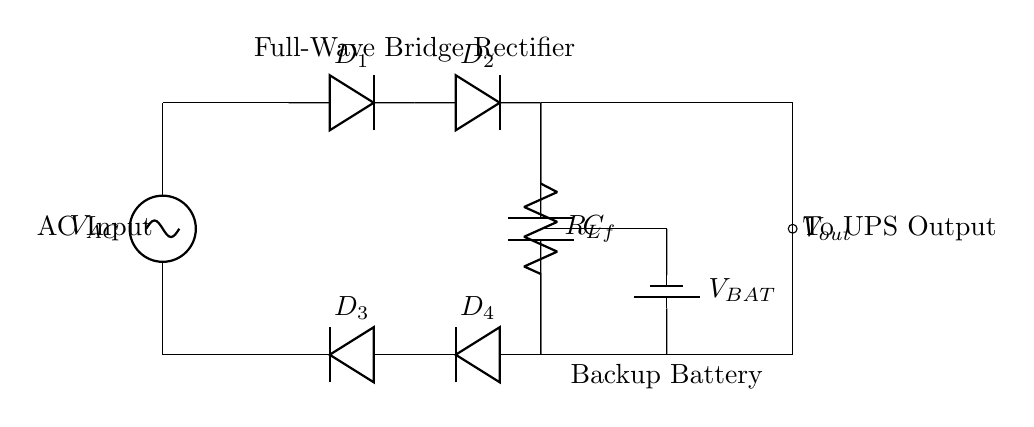What is the type of rectifier used in this circuit? The circuit diagram shows a full-wave bridge rectifier, which is designed to convert alternating current to direct current using four diodes arranged in a bridge configuration.
Answer: full-wave bridge rectifier How many diodes are in the circuit? The circuit contains four diodes, labeled D1, D2, D3, and D4, which are configured to create the bridge rectifier functionality.
Answer: four What does the capacitor C_f do in the circuit? Capacitor C_f serves to smooth the output voltage from the rectifier by filtering out fluctuations and providing a more stable direct current output, which is important for the load and battery charging.
Answer: smooth output voltage What is the purpose of the battery in this UPS system? The battery provides backup power to the load during power outages or disruptions in the AC input, ensuring that critical systems in the server room continue to operate without interruption.
Answer: backup power What is the role of the load resistor R_L? The load resistor R_L represents the connected device or system that consumes the output power from the rectifier, simulating the real load that the UPS is designed to support during normal operation.
Answer: simulates load When AC input voltage is applied, how does the output voltage behave? When AC input voltage is applied, the output voltage is pulsating direct current due to the full-wave rectification process, which means the output will show a waveform similar to the positive cycles of the input sine wave, effectively doubling the frequency of the output ripple.
Answer: pulsating direct current What is the significance of having a bridge configuration for the rectifier? The bridge configuration allows the rectifier to conduct during both halves of the AC input cycle, converting both positive and negative halves to direct current and providing a higher output voltage compared to a single diode rectification.
Answer: conducts both halves 